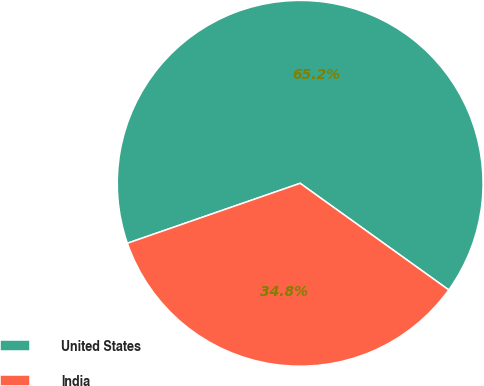<chart> <loc_0><loc_0><loc_500><loc_500><pie_chart><fcel>United States<fcel>India<nl><fcel>65.22%<fcel>34.78%<nl></chart> 